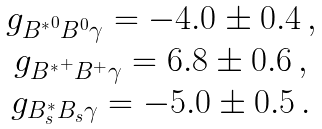<formula> <loc_0><loc_0><loc_500><loc_500>\begin{array} { c } g _ { { B ^ { \ast } } ^ { 0 } B ^ { 0 } \gamma } = - 4 . 0 \pm 0 . 4 \, , \\ g _ { { B ^ { \ast } } ^ { + } B ^ { + } \gamma } = 6 . 8 \pm 0 . 6 \, , \\ g _ { B _ { s } ^ { \ast } B _ { s } \gamma } = - 5 . 0 \pm 0 . 5 \, . \end{array}</formula> 